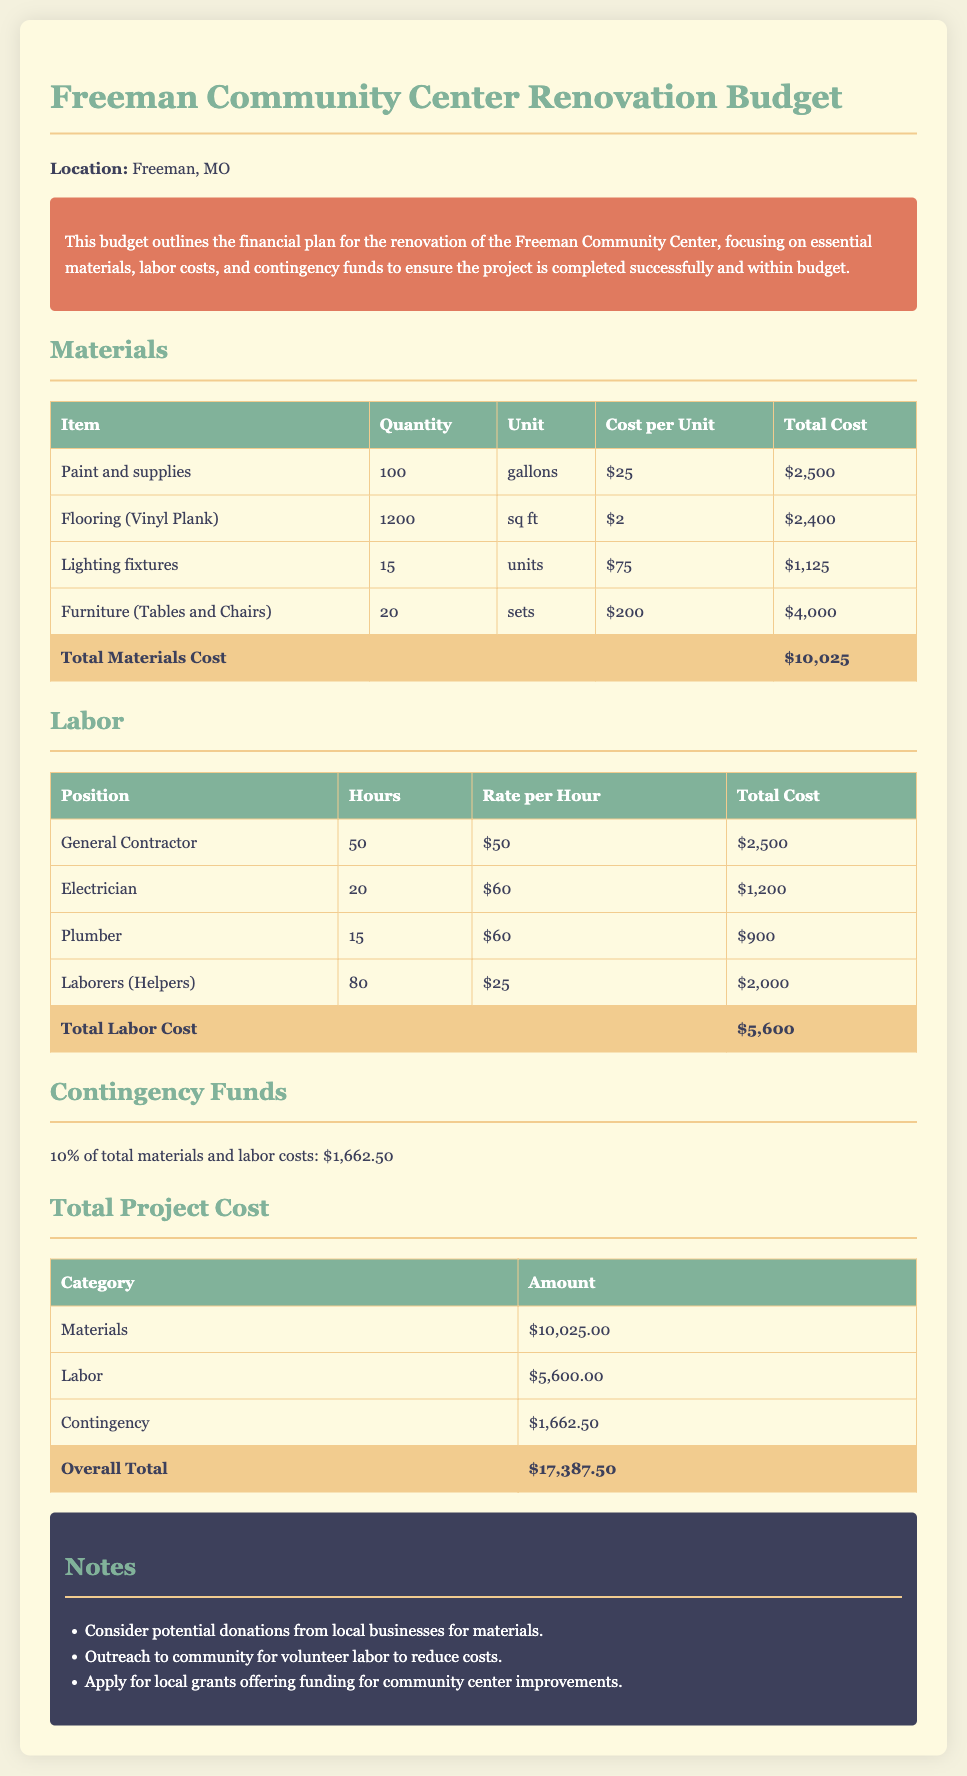What is the total materials cost? The total materials cost is found in the materials section, which adds up each item listed, totaling $10,025.
Answer: $10,025 How many gallons of paint are needed? The quantity of paint needed is specified in the materials table, indicating 100 gallons required.
Answer: 100 What is the cost of the electrician's labor? The cost for the electrician is calculated based on their hours and rate listed in the labor section, which totals $1,200.
Answer: $1,200 What percentage of the total costs are contingency funds? The contingency funds are calculated based on 10% of the total materials and labor costs, which is a specific calculation outlined in the document.
Answer: 10% What is the overall total project cost? The overall total project cost is listed in the total project cost section, combining materials, labor, and contingency funds, resulting in $17,387.50.
Answer: $17,387.50 How many sets of furniture are included in the budget? The number of furniture sets is indicated in the materials table, which specifies 20 sets of tables and chairs.
Answer: 20 What is the rate per hour for laborers? The rate for laborers is specified in the labor section, which states their hourly rate is $25.
Answer: $25 What is the total labor cost? The total labor cost includes the sums of all labor position costs detailed in the labor table, which totals $5,600.
Answer: $5,600 What additional funding sources are suggested? The notes section suggests considering potential donations from local businesses, outreach for volunteer labor, and applying for local grants.
Answer: Donations, Volunteers, Grants 